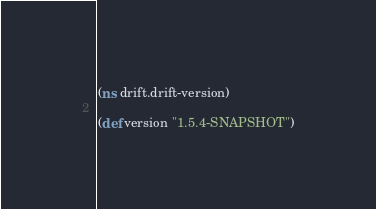<code> <loc_0><loc_0><loc_500><loc_500><_Clojure_>(ns drift.drift-version)

(def version "1.5.4-SNAPSHOT")</code> 